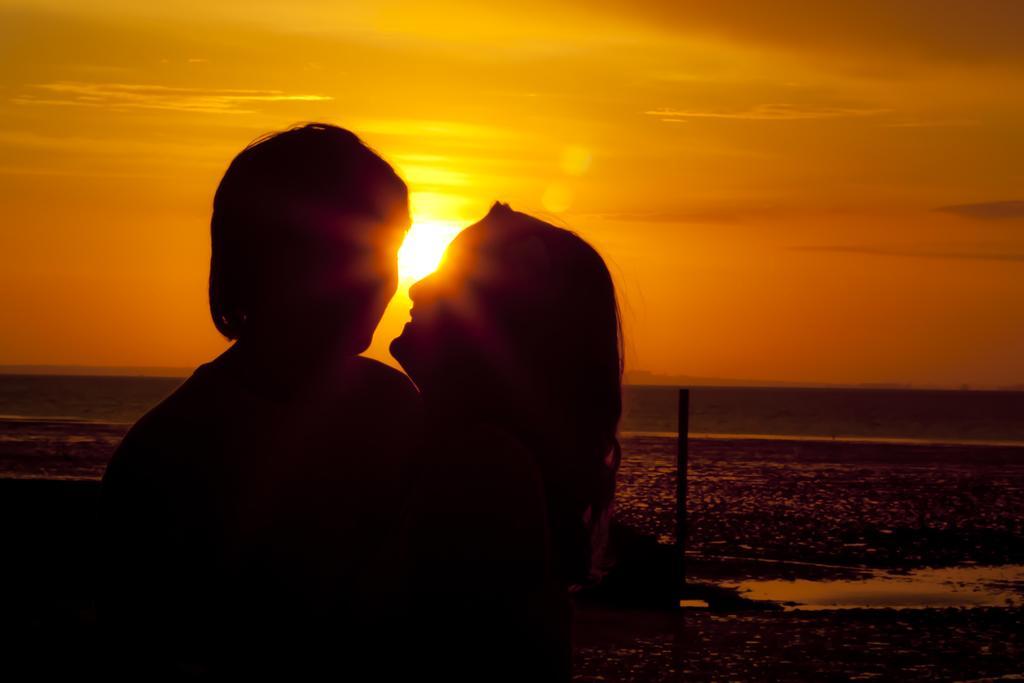Can you describe this image briefly? In the foreground of the image there are people. In the background of the image there is sky, sun and water. 